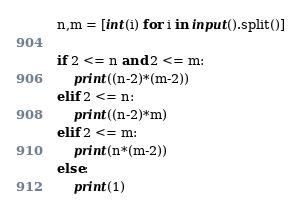Convert code to text. <code><loc_0><loc_0><loc_500><loc_500><_Python_>n,m = [int(i) for i in input().split()]

if 2 <= n and 2 <= m:
    print((n-2)*(m-2))
elif 2 <= n:
    print((n-2)*m)
elif 2 <= m:
    print(n*(m-2))
else:
    print(1)</code> 